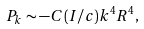<formula> <loc_0><loc_0><loc_500><loc_500>P _ { k } \sim - C ( I / c ) k ^ { 4 } R ^ { 4 } ,</formula> 